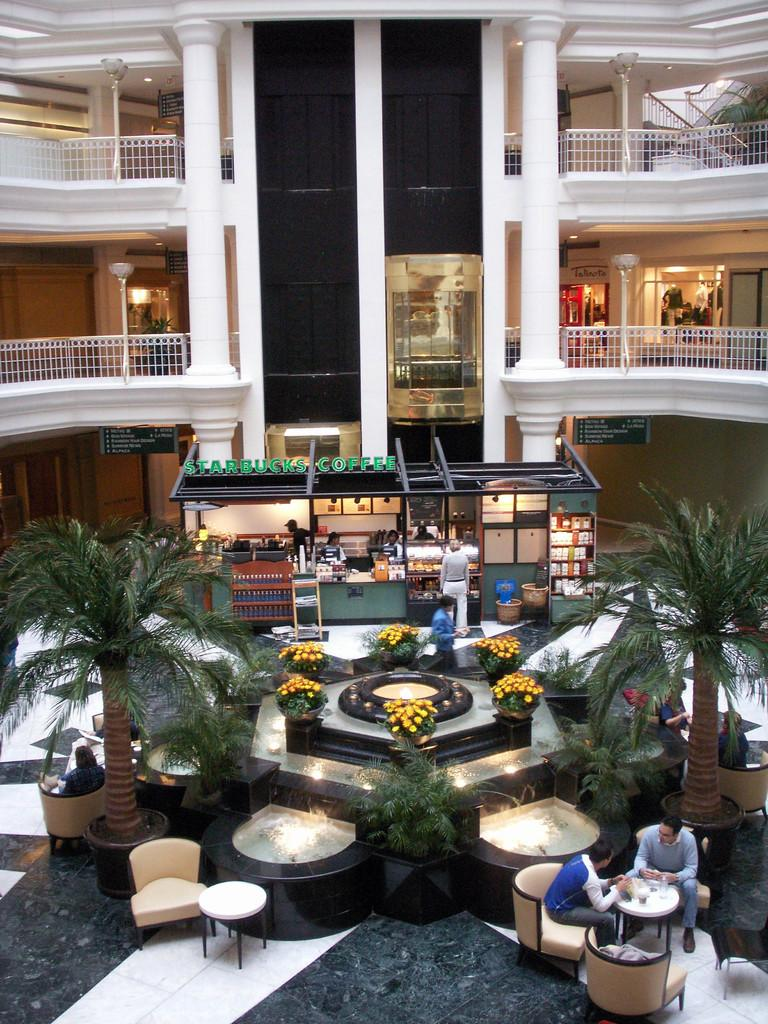Provide a one-sentence caption for the provided image. The lobby of what appears to be a hotel with a Starbucks. 